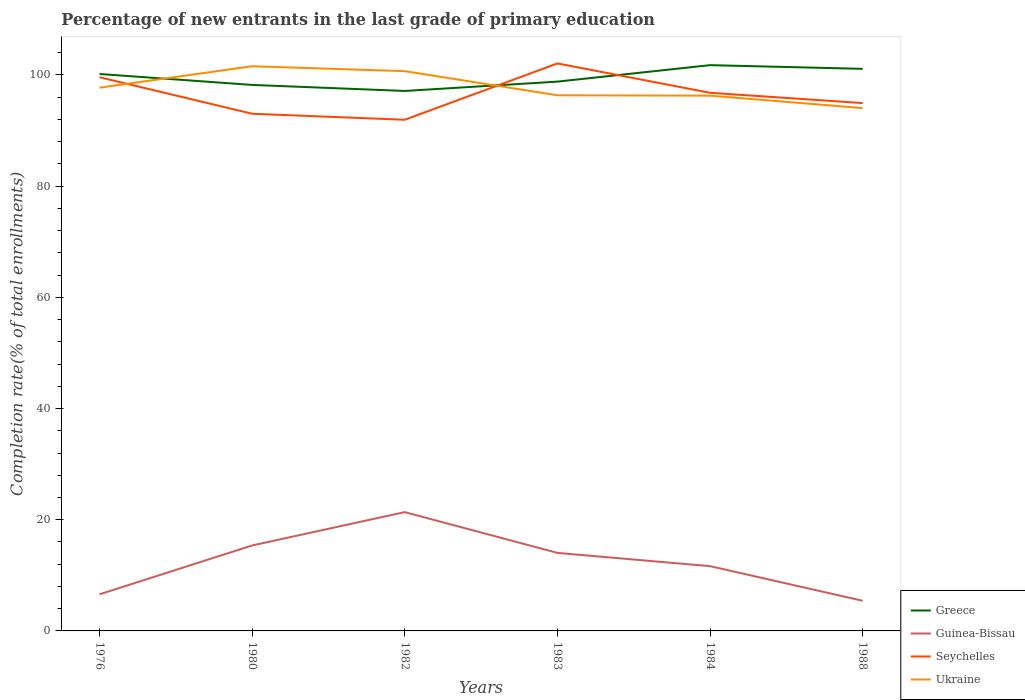How many different coloured lines are there?
Make the answer very short. 4. Does the line corresponding to Ukraine intersect with the line corresponding to Guinea-Bissau?
Your answer should be compact. No. Across all years, what is the maximum percentage of new entrants in Ukraine?
Offer a very short reply. 94.04. In which year was the percentage of new entrants in Ukraine maximum?
Your response must be concise. 1988. What is the total percentage of new entrants in Guinea-Bissau in the graph?
Give a very brief answer. -7.45. What is the difference between the highest and the second highest percentage of new entrants in Greece?
Your response must be concise. 4.64. What is the difference between the highest and the lowest percentage of new entrants in Ukraine?
Make the answer very short. 2. How many lines are there?
Keep it short and to the point. 4. How many years are there in the graph?
Your answer should be very brief. 6. Are the values on the major ticks of Y-axis written in scientific E-notation?
Provide a short and direct response. No. Does the graph contain grids?
Give a very brief answer. No. Where does the legend appear in the graph?
Give a very brief answer. Bottom right. How many legend labels are there?
Give a very brief answer. 4. How are the legend labels stacked?
Your answer should be compact. Vertical. What is the title of the graph?
Your answer should be compact. Percentage of new entrants in the last grade of primary education. Does "Middle East & North Africa (developing only)" appear as one of the legend labels in the graph?
Provide a succinct answer. No. What is the label or title of the Y-axis?
Offer a terse response. Completion rate(% of total enrollments). What is the Completion rate(% of total enrollments) in Greece in 1976?
Your answer should be very brief. 100.17. What is the Completion rate(% of total enrollments) of Guinea-Bissau in 1976?
Offer a very short reply. 6.58. What is the Completion rate(% of total enrollments) in Seychelles in 1976?
Your answer should be very brief. 99.58. What is the Completion rate(% of total enrollments) in Ukraine in 1976?
Offer a very short reply. 97.71. What is the Completion rate(% of total enrollments) in Greece in 1980?
Keep it short and to the point. 98.2. What is the Completion rate(% of total enrollments) in Guinea-Bissau in 1980?
Ensure brevity in your answer.  15.37. What is the Completion rate(% of total enrollments) of Seychelles in 1980?
Your answer should be very brief. 93.02. What is the Completion rate(% of total enrollments) of Ukraine in 1980?
Make the answer very short. 101.56. What is the Completion rate(% of total enrollments) in Greece in 1982?
Your response must be concise. 97.12. What is the Completion rate(% of total enrollments) of Guinea-Bissau in 1982?
Offer a terse response. 21.37. What is the Completion rate(% of total enrollments) in Seychelles in 1982?
Ensure brevity in your answer.  91.94. What is the Completion rate(% of total enrollments) of Ukraine in 1982?
Provide a short and direct response. 100.68. What is the Completion rate(% of total enrollments) of Greece in 1983?
Your answer should be compact. 98.8. What is the Completion rate(% of total enrollments) of Guinea-Bissau in 1983?
Your response must be concise. 14.03. What is the Completion rate(% of total enrollments) of Seychelles in 1983?
Offer a terse response. 102.07. What is the Completion rate(% of total enrollments) in Ukraine in 1983?
Ensure brevity in your answer.  96.34. What is the Completion rate(% of total enrollments) in Greece in 1984?
Your response must be concise. 101.76. What is the Completion rate(% of total enrollments) of Guinea-Bissau in 1984?
Your answer should be very brief. 11.65. What is the Completion rate(% of total enrollments) of Seychelles in 1984?
Your response must be concise. 96.79. What is the Completion rate(% of total enrollments) of Ukraine in 1984?
Provide a succinct answer. 96.27. What is the Completion rate(% of total enrollments) in Greece in 1988?
Offer a very short reply. 101.1. What is the Completion rate(% of total enrollments) of Guinea-Bissau in 1988?
Your answer should be compact. 5.42. What is the Completion rate(% of total enrollments) in Seychelles in 1988?
Make the answer very short. 94.94. What is the Completion rate(% of total enrollments) of Ukraine in 1988?
Provide a short and direct response. 94.04. Across all years, what is the maximum Completion rate(% of total enrollments) in Greece?
Make the answer very short. 101.76. Across all years, what is the maximum Completion rate(% of total enrollments) of Guinea-Bissau?
Your answer should be very brief. 21.37. Across all years, what is the maximum Completion rate(% of total enrollments) of Seychelles?
Provide a succinct answer. 102.07. Across all years, what is the maximum Completion rate(% of total enrollments) in Ukraine?
Provide a succinct answer. 101.56. Across all years, what is the minimum Completion rate(% of total enrollments) of Greece?
Your answer should be very brief. 97.12. Across all years, what is the minimum Completion rate(% of total enrollments) in Guinea-Bissau?
Give a very brief answer. 5.42. Across all years, what is the minimum Completion rate(% of total enrollments) of Seychelles?
Provide a succinct answer. 91.94. Across all years, what is the minimum Completion rate(% of total enrollments) of Ukraine?
Your answer should be very brief. 94.04. What is the total Completion rate(% of total enrollments) of Greece in the graph?
Give a very brief answer. 597.14. What is the total Completion rate(% of total enrollments) of Guinea-Bissau in the graph?
Provide a succinct answer. 74.43. What is the total Completion rate(% of total enrollments) in Seychelles in the graph?
Make the answer very short. 578.34. What is the total Completion rate(% of total enrollments) of Ukraine in the graph?
Your answer should be very brief. 586.6. What is the difference between the Completion rate(% of total enrollments) in Greece in 1976 and that in 1980?
Offer a terse response. 1.97. What is the difference between the Completion rate(% of total enrollments) of Guinea-Bissau in 1976 and that in 1980?
Ensure brevity in your answer.  -8.79. What is the difference between the Completion rate(% of total enrollments) of Seychelles in 1976 and that in 1980?
Your response must be concise. 6.56. What is the difference between the Completion rate(% of total enrollments) of Ukraine in 1976 and that in 1980?
Offer a very short reply. -3.86. What is the difference between the Completion rate(% of total enrollments) in Greece in 1976 and that in 1982?
Ensure brevity in your answer.  3.05. What is the difference between the Completion rate(% of total enrollments) in Guinea-Bissau in 1976 and that in 1982?
Make the answer very short. -14.78. What is the difference between the Completion rate(% of total enrollments) in Seychelles in 1976 and that in 1982?
Make the answer very short. 7.64. What is the difference between the Completion rate(% of total enrollments) of Ukraine in 1976 and that in 1982?
Provide a succinct answer. -2.97. What is the difference between the Completion rate(% of total enrollments) of Greece in 1976 and that in 1983?
Offer a very short reply. 1.37. What is the difference between the Completion rate(% of total enrollments) in Guinea-Bissau in 1976 and that in 1983?
Provide a short and direct response. -7.45. What is the difference between the Completion rate(% of total enrollments) in Seychelles in 1976 and that in 1983?
Provide a short and direct response. -2.48. What is the difference between the Completion rate(% of total enrollments) in Ukraine in 1976 and that in 1983?
Keep it short and to the point. 1.37. What is the difference between the Completion rate(% of total enrollments) in Greece in 1976 and that in 1984?
Your response must be concise. -1.59. What is the difference between the Completion rate(% of total enrollments) of Guinea-Bissau in 1976 and that in 1984?
Keep it short and to the point. -5.07. What is the difference between the Completion rate(% of total enrollments) in Seychelles in 1976 and that in 1984?
Offer a terse response. 2.79. What is the difference between the Completion rate(% of total enrollments) in Ukraine in 1976 and that in 1984?
Keep it short and to the point. 1.43. What is the difference between the Completion rate(% of total enrollments) of Greece in 1976 and that in 1988?
Offer a terse response. -0.93. What is the difference between the Completion rate(% of total enrollments) of Guinea-Bissau in 1976 and that in 1988?
Your answer should be compact. 1.16. What is the difference between the Completion rate(% of total enrollments) of Seychelles in 1976 and that in 1988?
Keep it short and to the point. 4.64. What is the difference between the Completion rate(% of total enrollments) in Ukraine in 1976 and that in 1988?
Your answer should be very brief. 3.67. What is the difference between the Completion rate(% of total enrollments) in Greece in 1980 and that in 1982?
Provide a succinct answer. 1.09. What is the difference between the Completion rate(% of total enrollments) in Guinea-Bissau in 1980 and that in 1982?
Provide a succinct answer. -5.99. What is the difference between the Completion rate(% of total enrollments) of Seychelles in 1980 and that in 1982?
Give a very brief answer. 1.08. What is the difference between the Completion rate(% of total enrollments) of Ukraine in 1980 and that in 1982?
Your answer should be very brief. 0.88. What is the difference between the Completion rate(% of total enrollments) of Greece in 1980 and that in 1983?
Your answer should be very brief. -0.59. What is the difference between the Completion rate(% of total enrollments) in Guinea-Bissau in 1980 and that in 1983?
Your answer should be very brief. 1.34. What is the difference between the Completion rate(% of total enrollments) in Seychelles in 1980 and that in 1983?
Ensure brevity in your answer.  -9.05. What is the difference between the Completion rate(% of total enrollments) of Ukraine in 1980 and that in 1983?
Ensure brevity in your answer.  5.22. What is the difference between the Completion rate(% of total enrollments) in Greece in 1980 and that in 1984?
Your response must be concise. -3.56. What is the difference between the Completion rate(% of total enrollments) of Guinea-Bissau in 1980 and that in 1984?
Your answer should be very brief. 3.72. What is the difference between the Completion rate(% of total enrollments) in Seychelles in 1980 and that in 1984?
Provide a short and direct response. -3.77. What is the difference between the Completion rate(% of total enrollments) of Ukraine in 1980 and that in 1984?
Make the answer very short. 5.29. What is the difference between the Completion rate(% of total enrollments) in Greece in 1980 and that in 1988?
Provide a succinct answer. -2.89. What is the difference between the Completion rate(% of total enrollments) of Guinea-Bissau in 1980 and that in 1988?
Offer a very short reply. 9.95. What is the difference between the Completion rate(% of total enrollments) in Seychelles in 1980 and that in 1988?
Provide a succinct answer. -1.92. What is the difference between the Completion rate(% of total enrollments) in Ukraine in 1980 and that in 1988?
Ensure brevity in your answer.  7.53. What is the difference between the Completion rate(% of total enrollments) of Greece in 1982 and that in 1983?
Provide a succinct answer. -1.68. What is the difference between the Completion rate(% of total enrollments) in Guinea-Bissau in 1982 and that in 1983?
Make the answer very short. 7.33. What is the difference between the Completion rate(% of total enrollments) in Seychelles in 1982 and that in 1983?
Your answer should be very brief. -10.13. What is the difference between the Completion rate(% of total enrollments) in Ukraine in 1982 and that in 1983?
Your response must be concise. 4.34. What is the difference between the Completion rate(% of total enrollments) in Greece in 1982 and that in 1984?
Give a very brief answer. -4.64. What is the difference between the Completion rate(% of total enrollments) of Guinea-Bissau in 1982 and that in 1984?
Make the answer very short. 9.72. What is the difference between the Completion rate(% of total enrollments) in Seychelles in 1982 and that in 1984?
Make the answer very short. -4.85. What is the difference between the Completion rate(% of total enrollments) of Ukraine in 1982 and that in 1984?
Keep it short and to the point. 4.41. What is the difference between the Completion rate(% of total enrollments) of Greece in 1982 and that in 1988?
Your answer should be very brief. -3.98. What is the difference between the Completion rate(% of total enrollments) in Guinea-Bissau in 1982 and that in 1988?
Your answer should be very brief. 15.94. What is the difference between the Completion rate(% of total enrollments) of Seychelles in 1982 and that in 1988?
Ensure brevity in your answer.  -3. What is the difference between the Completion rate(% of total enrollments) of Ukraine in 1982 and that in 1988?
Your answer should be compact. 6.64. What is the difference between the Completion rate(% of total enrollments) of Greece in 1983 and that in 1984?
Keep it short and to the point. -2.96. What is the difference between the Completion rate(% of total enrollments) of Guinea-Bissau in 1983 and that in 1984?
Offer a terse response. 2.39. What is the difference between the Completion rate(% of total enrollments) in Seychelles in 1983 and that in 1984?
Give a very brief answer. 5.28. What is the difference between the Completion rate(% of total enrollments) in Ukraine in 1983 and that in 1984?
Your answer should be very brief. 0.07. What is the difference between the Completion rate(% of total enrollments) in Greece in 1983 and that in 1988?
Offer a very short reply. -2.3. What is the difference between the Completion rate(% of total enrollments) in Guinea-Bissau in 1983 and that in 1988?
Offer a very short reply. 8.61. What is the difference between the Completion rate(% of total enrollments) of Seychelles in 1983 and that in 1988?
Provide a succinct answer. 7.13. What is the difference between the Completion rate(% of total enrollments) of Ukraine in 1983 and that in 1988?
Keep it short and to the point. 2.3. What is the difference between the Completion rate(% of total enrollments) in Greece in 1984 and that in 1988?
Keep it short and to the point. 0.66. What is the difference between the Completion rate(% of total enrollments) of Guinea-Bissau in 1984 and that in 1988?
Give a very brief answer. 6.22. What is the difference between the Completion rate(% of total enrollments) of Seychelles in 1984 and that in 1988?
Ensure brevity in your answer.  1.85. What is the difference between the Completion rate(% of total enrollments) in Ukraine in 1984 and that in 1988?
Your response must be concise. 2.24. What is the difference between the Completion rate(% of total enrollments) in Greece in 1976 and the Completion rate(% of total enrollments) in Guinea-Bissau in 1980?
Your answer should be very brief. 84.8. What is the difference between the Completion rate(% of total enrollments) of Greece in 1976 and the Completion rate(% of total enrollments) of Seychelles in 1980?
Give a very brief answer. 7.15. What is the difference between the Completion rate(% of total enrollments) in Greece in 1976 and the Completion rate(% of total enrollments) in Ukraine in 1980?
Offer a very short reply. -1.4. What is the difference between the Completion rate(% of total enrollments) of Guinea-Bissau in 1976 and the Completion rate(% of total enrollments) of Seychelles in 1980?
Offer a terse response. -86.44. What is the difference between the Completion rate(% of total enrollments) in Guinea-Bissau in 1976 and the Completion rate(% of total enrollments) in Ukraine in 1980?
Provide a short and direct response. -94.98. What is the difference between the Completion rate(% of total enrollments) in Seychelles in 1976 and the Completion rate(% of total enrollments) in Ukraine in 1980?
Your answer should be very brief. -1.98. What is the difference between the Completion rate(% of total enrollments) in Greece in 1976 and the Completion rate(% of total enrollments) in Guinea-Bissau in 1982?
Make the answer very short. 78.8. What is the difference between the Completion rate(% of total enrollments) of Greece in 1976 and the Completion rate(% of total enrollments) of Seychelles in 1982?
Ensure brevity in your answer.  8.23. What is the difference between the Completion rate(% of total enrollments) of Greece in 1976 and the Completion rate(% of total enrollments) of Ukraine in 1982?
Keep it short and to the point. -0.51. What is the difference between the Completion rate(% of total enrollments) in Guinea-Bissau in 1976 and the Completion rate(% of total enrollments) in Seychelles in 1982?
Your answer should be very brief. -85.36. What is the difference between the Completion rate(% of total enrollments) in Guinea-Bissau in 1976 and the Completion rate(% of total enrollments) in Ukraine in 1982?
Your response must be concise. -94.1. What is the difference between the Completion rate(% of total enrollments) in Seychelles in 1976 and the Completion rate(% of total enrollments) in Ukraine in 1982?
Provide a succinct answer. -1.1. What is the difference between the Completion rate(% of total enrollments) of Greece in 1976 and the Completion rate(% of total enrollments) of Guinea-Bissau in 1983?
Make the answer very short. 86.13. What is the difference between the Completion rate(% of total enrollments) of Greece in 1976 and the Completion rate(% of total enrollments) of Seychelles in 1983?
Offer a terse response. -1.9. What is the difference between the Completion rate(% of total enrollments) in Greece in 1976 and the Completion rate(% of total enrollments) in Ukraine in 1983?
Give a very brief answer. 3.83. What is the difference between the Completion rate(% of total enrollments) in Guinea-Bissau in 1976 and the Completion rate(% of total enrollments) in Seychelles in 1983?
Your response must be concise. -95.48. What is the difference between the Completion rate(% of total enrollments) of Guinea-Bissau in 1976 and the Completion rate(% of total enrollments) of Ukraine in 1983?
Give a very brief answer. -89.76. What is the difference between the Completion rate(% of total enrollments) of Seychelles in 1976 and the Completion rate(% of total enrollments) of Ukraine in 1983?
Your answer should be compact. 3.24. What is the difference between the Completion rate(% of total enrollments) in Greece in 1976 and the Completion rate(% of total enrollments) in Guinea-Bissau in 1984?
Ensure brevity in your answer.  88.52. What is the difference between the Completion rate(% of total enrollments) of Greece in 1976 and the Completion rate(% of total enrollments) of Seychelles in 1984?
Your answer should be very brief. 3.38. What is the difference between the Completion rate(% of total enrollments) of Greece in 1976 and the Completion rate(% of total enrollments) of Ukraine in 1984?
Your answer should be compact. 3.89. What is the difference between the Completion rate(% of total enrollments) in Guinea-Bissau in 1976 and the Completion rate(% of total enrollments) in Seychelles in 1984?
Your answer should be compact. -90.21. What is the difference between the Completion rate(% of total enrollments) in Guinea-Bissau in 1976 and the Completion rate(% of total enrollments) in Ukraine in 1984?
Provide a short and direct response. -89.69. What is the difference between the Completion rate(% of total enrollments) in Seychelles in 1976 and the Completion rate(% of total enrollments) in Ukraine in 1984?
Your answer should be very brief. 3.31. What is the difference between the Completion rate(% of total enrollments) in Greece in 1976 and the Completion rate(% of total enrollments) in Guinea-Bissau in 1988?
Your answer should be compact. 94.74. What is the difference between the Completion rate(% of total enrollments) in Greece in 1976 and the Completion rate(% of total enrollments) in Seychelles in 1988?
Offer a terse response. 5.23. What is the difference between the Completion rate(% of total enrollments) in Greece in 1976 and the Completion rate(% of total enrollments) in Ukraine in 1988?
Ensure brevity in your answer.  6.13. What is the difference between the Completion rate(% of total enrollments) of Guinea-Bissau in 1976 and the Completion rate(% of total enrollments) of Seychelles in 1988?
Provide a succinct answer. -88.35. What is the difference between the Completion rate(% of total enrollments) in Guinea-Bissau in 1976 and the Completion rate(% of total enrollments) in Ukraine in 1988?
Ensure brevity in your answer.  -87.45. What is the difference between the Completion rate(% of total enrollments) of Seychelles in 1976 and the Completion rate(% of total enrollments) of Ukraine in 1988?
Provide a succinct answer. 5.55. What is the difference between the Completion rate(% of total enrollments) in Greece in 1980 and the Completion rate(% of total enrollments) in Guinea-Bissau in 1982?
Provide a succinct answer. 76.84. What is the difference between the Completion rate(% of total enrollments) of Greece in 1980 and the Completion rate(% of total enrollments) of Seychelles in 1982?
Ensure brevity in your answer.  6.26. What is the difference between the Completion rate(% of total enrollments) in Greece in 1980 and the Completion rate(% of total enrollments) in Ukraine in 1982?
Make the answer very short. -2.48. What is the difference between the Completion rate(% of total enrollments) in Guinea-Bissau in 1980 and the Completion rate(% of total enrollments) in Seychelles in 1982?
Ensure brevity in your answer.  -76.57. What is the difference between the Completion rate(% of total enrollments) in Guinea-Bissau in 1980 and the Completion rate(% of total enrollments) in Ukraine in 1982?
Provide a succinct answer. -85.31. What is the difference between the Completion rate(% of total enrollments) in Seychelles in 1980 and the Completion rate(% of total enrollments) in Ukraine in 1982?
Make the answer very short. -7.66. What is the difference between the Completion rate(% of total enrollments) in Greece in 1980 and the Completion rate(% of total enrollments) in Guinea-Bissau in 1983?
Offer a very short reply. 84.17. What is the difference between the Completion rate(% of total enrollments) in Greece in 1980 and the Completion rate(% of total enrollments) in Seychelles in 1983?
Your answer should be compact. -3.86. What is the difference between the Completion rate(% of total enrollments) of Greece in 1980 and the Completion rate(% of total enrollments) of Ukraine in 1983?
Your answer should be compact. 1.86. What is the difference between the Completion rate(% of total enrollments) in Guinea-Bissau in 1980 and the Completion rate(% of total enrollments) in Seychelles in 1983?
Keep it short and to the point. -86.69. What is the difference between the Completion rate(% of total enrollments) of Guinea-Bissau in 1980 and the Completion rate(% of total enrollments) of Ukraine in 1983?
Offer a very short reply. -80.97. What is the difference between the Completion rate(% of total enrollments) of Seychelles in 1980 and the Completion rate(% of total enrollments) of Ukraine in 1983?
Your answer should be very brief. -3.32. What is the difference between the Completion rate(% of total enrollments) of Greece in 1980 and the Completion rate(% of total enrollments) of Guinea-Bissau in 1984?
Provide a succinct answer. 86.55. What is the difference between the Completion rate(% of total enrollments) in Greece in 1980 and the Completion rate(% of total enrollments) in Seychelles in 1984?
Provide a succinct answer. 1.41. What is the difference between the Completion rate(% of total enrollments) of Greece in 1980 and the Completion rate(% of total enrollments) of Ukraine in 1984?
Offer a terse response. 1.93. What is the difference between the Completion rate(% of total enrollments) of Guinea-Bissau in 1980 and the Completion rate(% of total enrollments) of Seychelles in 1984?
Your answer should be very brief. -81.42. What is the difference between the Completion rate(% of total enrollments) of Guinea-Bissau in 1980 and the Completion rate(% of total enrollments) of Ukraine in 1984?
Make the answer very short. -80.9. What is the difference between the Completion rate(% of total enrollments) in Seychelles in 1980 and the Completion rate(% of total enrollments) in Ukraine in 1984?
Keep it short and to the point. -3.25. What is the difference between the Completion rate(% of total enrollments) in Greece in 1980 and the Completion rate(% of total enrollments) in Guinea-Bissau in 1988?
Your response must be concise. 92.78. What is the difference between the Completion rate(% of total enrollments) of Greece in 1980 and the Completion rate(% of total enrollments) of Seychelles in 1988?
Provide a short and direct response. 3.27. What is the difference between the Completion rate(% of total enrollments) in Greece in 1980 and the Completion rate(% of total enrollments) in Ukraine in 1988?
Make the answer very short. 4.17. What is the difference between the Completion rate(% of total enrollments) of Guinea-Bissau in 1980 and the Completion rate(% of total enrollments) of Seychelles in 1988?
Ensure brevity in your answer.  -79.56. What is the difference between the Completion rate(% of total enrollments) in Guinea-Bissau in 1980 and the Completion rate(% of total enrollments) in Ukraine in 1988?
Make the answer very short. -78.66. What is the difference between the Completion rate(% of total enrollments) of Seychelles in 1980 and the Completion rate(% of total enrollments) of Ukraine in 1988?
Offer a terse response. -1.02. What is the difference between the Completion rate(% of total enrollments) in Greece in 1982 and the Completion rate(% of total enrollments) in Guinea-Bissau in 1983?
Your answer should be very brief. 83.08. What is the difference between the Completion rate(% of total enrollments) of Greece in 1982 and the Completion rate(% of total enrollments) of Seychelles in 1983?
Make the answer very short. -4.95. What is the difference between the Completion rate(% of total enrollments) in Greece in 1982 and the Completion rate(% of total enrollments) in Ukraine in 1983?
Provide a succinct answer. 0.78. What is the difference between the Completion rate(% of total enrollments) of Guinea-Bissau in 1982 and the Completion rate(% of total enrollments) of Seychelles in 1983?
Offer a very short reply. -80.7. What is the difference between the Completion rate(% of total enrollments) of Guinea-Bissau in 1982 and the Completion rate(% of total enrollments) of Ukraine in 1983?
Keep it short and to the point. -74.97. What is the difference between the Completion rate(% of total enrollments) in Seychelles in 1982 and the Completion rate(% of total enrollments) in Ukraine in 1983?
Make the answer very short. -4.4. What is the difference between the Completion rate(% of total enrollments) in Greece in 1982 and the Completion rate(% of total enrollments) in Guinea-Bissau in 1984?
Your response must be concise. 85.47. What is the difference between the Completion rate(% of total enrollments) of Greece in 1982 and the Completion rate(% of total enrollments) of Seychelles in 1984?
Keep it short and to the point. 0.33. What is the difference between the Completion rate(% of total enrollments) of Greece in 1982 and the Completion rate(% of total enrollments) of Ukraine in 1984?
Keep it short and to the point. 0.84. What is the difference between the Completion rate(% of total enrollments) of Guinea-Bissau in 1982 and the Completion rate(% of total enrollments) of Seychelles in 1984?
Give a very brief answer. -75.42. What is the difference between the Completion rate(% of total enrollments) in Guinea-Bissau in 1982 and the Completion rate(% of total enrollments) in Ukraine in 1984?
Provide a succinct answer. -74.91. What is the difference between the Completion rate(% of total enrollments) of Seychelles in 1982 and the Completion rate(% of total enrollments) of Ukraine in 1984?
Offer a very short reply. -4.33. What is the difference between the Completion rate(% of total enrollments) of Greece in 1982 and the Completion rate(% of total enrollments) of Guinea-Bissau in 1988?
Offer a very short reply. 91.69. What is the difference between the Completion rate(% of total enrollments) in Greece in 1982 and the Completion rate(% of total enrollments) in Seychelles in 1988?
Your answer should be very brief. 2.18. What is the difference between the Completion rate(% of total enrollments) in Greece in 1982 and the Completion rate(% of total enrollments) in Ukraine in 1988?
Give a very brief answer. 3.08. What is the difference between the Completion rate(% of total enrollments) in Guinea-Bissau in 1982 and the Completion rate(% of total enrollments) in Seychelles in 1988?
Keep it short and to the point. -73.57. What is the difference between the Completion rate(% of total enrollments) of Guinea-Bissau in 1982 and the Completion rate(% of total enrollments) of Ukraine in 1988?
Offer a very short reply. -72.67. What is the difference between the Completion rate(% of total enrollments) in Seychelles in 1982 and the Completion rate(% of total enrollments) in Ukraine in 1988?
Provide a short and direct response. -2.1. What is the difference between the Completion rate(% of total enrollments) of Greece in 1983 and the Completion rate(% of total enrollments) of Guinea-Bissau in 1984?
Ensure brevity in your answer.  87.15. What is the difference between the Completion rate(% of total enrollments) of Greece in 1983 and the Completion rate(% of total enrollments) of Seychelles in 1984?
Offer a terse response. 2.01. What is the difference between the Completion rate(% of total enrollments) of Greece in 1983 and the Completion rate(% of total enrollments) of Ukraine in 1984?
Your response must be concise. 2.52. What is the difference between the Completion rate(% of total enrollments) in Guinea-Bissau in 1983 and the Completion rate(% of total enrollments) in Seychelles in 1984?
Make the answer very short. -82.76. What is the difference between the Completion rate(% of total enrollments) in Guinea-Bissau in 1983 and the Completion rate(% of total enrollments) in Ukraine in 1984?
Offer a very short reply. -82.24. What is the difference between the Completion rate(% of total enrollments) of Seychelles in 1983 and the Completion rate(% of total enrollments) of Ukraine in 1984?
Your response must be concise. 5.79. What is the difference between the Completion rate(% of total enrollments) in Greece in 1983 and the Completion rate(% of total enrollments) in Guinea-Bissau in 1988?
Offer a very short reply. 93.37. What is the difference between the Completion rate(% of total enrollments) in Greece in 1983 and the Completion rate(% of total enrollments) in Seychelles in 1988?
Give a very brief answer. 3.86. What is the difference between the Completion rate(% of total enrollments) in Greece in 1983 and the Completion rate(% of total enrollments) in Ukraine in 1988?
Give a very brief answer. 4.76. What is the difference between the Completion rate(% of total enrollments) in Guinea-Bissau in 1983 and the Completion rate(% of total enrollments) in Seychelles in 1988?
Give a very brief answer. -80.9. What is the difference between the Completion rate(% of total enrollments) in Guinea-Bissau in 1983 and the Completion rate(% of total enrollments) in Ukraine in 1988?
Give a very brief answer. -80. What is the difference between the Completion rate(% of total enrollments) in Seychelles in 1983 and the Completion rate(% of total enrollments) in Ukraine in 1988?
Ensure brevity in your answer.  8.03. What is the difference between the Completion rate(% of total enrollments) in Greece in 1984 and the Completion rate(% of total enrollments) in Guinea-Bissau in 1988?
Your response must be concise. 96.33. What is the difference between the Completion rate(% of total enrollments) in Greece in 1984 and the Completion rate(% of total enrollments) in Seychelles in 1988?
Offer a very short reply. 6.82. What is the difference between the Completion rate(% of total enrollments) in Greece in 1984 and the Completion rate(% of total enrollments) in Ukraine in 1988?
Make the answer very short. 7.72. What is the difference between the Completion rate(% of total enrollments) in Guinea-Bissau in 1984 and the Completion rate(% of total enrollments) in Seychelles in 1988?
Your answer should be compact. -83.29. What is the difference between the Completion rate(% of total enrollments) in Guinea-Bissau in 1984 and the Completion rate(% of total enrollments) in Ukraine in 1988?
Your response must be concise. -82.39. What is the difference between the Completion rate(% of total enrollments) in Seychelles in 1984 and the Completion rate(% of total enrollments) in Ukraine in 1988?
Give a very brief answer. 2.75. What is the average Completion rate(% of total enrollments) in Greece per year?
Provide a short and direct response. 99.52. What is the average Completion rate(% of total enrollments) of Guinea-Bissau per year?
Your answer should be very brief. 12.41. What is the average Completion rate(% of total enrollments) in Seychelles per year?
Ensure brevity in your answer.  96.39. What is the average Completion rate(% of total enrollments) of Ukraine per year?
Make the answer very short. 97.77. In the year 1976, what is the difference between the Completion rate(% of total enrollments) of Greece and Completion rate(% of total enrollments) of Guinea-Bissau?
Keep it short and to the point. 93.59. In the year 1976, what is the difference between the Completion rate(% of total enrollments) in Greece and Completion rate(% of total enrollments) in Seychelles?
Your response must be concise. 0.59. In the year 1976, what is the difference between the Completion rate(% of total enrollments) of Greece and Completion rate(% of total enrollments) of Ukraine?
Give a very brief answer. 2.46. In the year 1976, what is the difference between the Completion rate(% of total enrollments) in Guinea-Bissau and Completion rate(% of total enrollments) in Seychelles?
Your answer should be very brief. -93. In the year 1976, what is the difference between the Completion rate(% of total enrollments) in Guinea-Bissau and Completion rate(% of total enrollments) in Ukraine?
Provide a succinct answer. -91.12. In the year 1976, what is the difference between the Completion rate(% of total enrollments) in Seychelles and Completion rate(% of total enrollments) in Ukraine?
Offer a terse response. 1.88. In the year 1980, what is the difference between the Completion rate(% of total enrollments) of Greece and Completion rate(% of total enrollments) of Guinea-Bissau?
Provide a short and direct response. 82.83. In the year 1980, what is the difference between the Completion rate(% of total enrollments) of Greece and Completion rate(% of total enrollments) of Seychelles?
Your answer should be very brief. 5.18. In the year 1980, what is the difference between the Completion rate(% of total enrollments) in Greece and Completion rate(% of total enrollments) in Ukraine?
Make the answer very short. -3.36. In the year 1980, what is the difference between the Completion rate(% of total enrollments) in Guinea-Bissau and Completion rate(% of total enrollments) in Seychelles?
Your response must be concise. -77.65. In the year 1980, what is the difference between the Completion rate(% of total enrollments) in Guinea-Bissau and Completion rate(% of total enrollments) in Ukraine?
Provide a short and direct response. -86.19. In the year 1980, what is the difference between the Completion rate(% of total enrollments) in Seychelles and Completion rate(% of total enrollments) in Ukraine?
Your answer should be compact. -8.55. In the year 1982, what is the difference between the Completion rate(% of total enrollments) of Greece and Completion rate(% of total enrollments) of Guinea-Bissau?
Provide a succinct answer. 75.75. In the year 1982, what is the difference between the Completion rate(% of total enrollments) of Greece and Completion rate(% of total enrollments) of Seychelles?
Offer a very short reply. 5.18. In the year 1982, what is the difference between the Completion rate(% of total enrollments) in Greece and Completion rate(% of total enrollments) in Ukraine?
Make the answer very short. -3.56. In the year 1982, what is the difference between the Completion rate(% of total enrollments) of Guinea-Bissau and Completion rate(% of total enrollments) of Seychelles?
Ensure brevity in your answer.  -70.57. In the year 1982, what is the difference between the Completion rate(% of total enrollments) of Guinea-Bissau and Completion rate(% of total enrollments) of Ukraine?
Provide a succinct answer. -79.31. In the year 1982, what is the difference between the Completion rate(% of total enrollments) of Seychelles and Completion rate(% of total enrollments) of Ukraine?
Offer a terse response. -8.74. In the year 1983, what is the difference between the Completion rate(% of total enrollments) in Greece and Completion rate(% of total enrollments) in Guinea-Bissau?
Your response must be concise. 84.76. In the year 1983, what is the difference between the Completion rate(% of total enrollments) in Greece and Completion rate(% of total enrollments) in Seychelles?
Offer a terse response. -3.27. In the year 1983, what is the difference between the Completion rate(% of total enrollments) of Greece and Completion rate(% of total enrollments) of Ukraine?
Provide a succinct answer. 2.46. In the year 1983, what is the difference between the Completion rate(% of total enrollments) in Guinea-Bissau and Completion rate(% of total enrollments) in Seychelles?
Offer a terse response. -88.03. In the year 1983, what is the difference between the Completion rate(% of total enrollments) in Guinea-Bissau and Completion rate(% of total enrollments) in Ukraine?
Your answer should be very brief. -82.31. In the year 1983, what is the difference between the Completion rate(% of total enrollments) in Seychelles and Completion rate(% of total enrollments) in Ukraine?
Offer a very short reply. 5.73. In the year 1984, what is the difference between the Completion rate(% of total enrollments) in Greece and Completion rate(% of total enrollments) in Guinea-Bissau?
Make the answer very short. 90.11. In the year 1984, what is the difference between the Completion rate(% of total enrollments) of Greece and Completion rate(% of total enrollments) of Seychelles?
Make the answer very short. 4.97. In the year 1984, what is the difference between the Completion rate(% of total enrollments) in Greece and Completion rate(% of total enrollments) in Ukraine?
Your response must be concise. 5.48. In the year 1984, what is the difference between the Completion rate(% of total enrollments) of Guinea-Bissau and Completion rate(% of total enrollments) of Seychelles?
Your answer should be very brief. -85.14. In the year 1984, what is the difference between the Completion rate(% of total enrollments) of Guinea-Bissau and Completion rate(% of total enrollments) of Ukraine?
Offer a very short reply. -84.62. In the year 1984, what is the difference between the Completion rate(% of total enrollments) of Seychelles and Completion rate(% of total enrollments) of Ukraine?
Your response must be concise. 0.52. In the year 1988, what is the difference between the Completion rate(% of total enrollments) of Greece and Completion rate(% of total enrollments) of Guinea-Bissau?
Your response must be concise. 95.67. In the year 1988, what is the difference between the Completion rate(% of total enrollments) of Greece and Completion rate(% of total enrollments) of Seychelles?
Provide a short and direct response. 6.16. In the year 1988, what is the difference between the Completion rate(% of total enrollments) in Greece and Completion rate(% of total enrollments) in Ukraine?
Provide a succinct answer. 7.06. In the year 1988, what is the difference between the Completion rate(% of total enrollments) in Guinea-Bissau and Completion rate(% of total enrollments) in Seychelles?
Ensure brevity in your answer.  -89.51. In the year 1988, what is the difference between the Completion rate(% of total enrollments) in Guinea-Bissau and Completion rate(% of total enrollments) in Ukraine?
Give a very brief answer. -88.61. In the year 1988, what is the difference between the Completion rate(% of total enrollments) of Seychelles and Completion rate(% of total enrollments) of Ukraine?
Ensure brevity in your answer.  0.9. What is the ratio of the Completion rate(% of total enrollments) of Greece in 1976 to that in 1980?
Make the answer very short. 1.02. What is the ratio of the Completion rate(% of total enrollments) in Guinea-Bissau in 1976 to that in 1980?
Give a very brief answer. 0.43. What is the ratio of the Completion rate(% of total enrollments) of Seychelles in 1976 to that in 1980?
Keep it short and to the point. 1.07. What is the ratio of the Completion rate(% of total enrollments) of Greece in 1976 to that in 1982?
Offer a very short reply. 1.03. What is the ratio of the Completion rate(% of total enrollments) of Guinea-Bissau in 1976 to that in 1982?
Keep it short and to the point. 0.31. What is the ratio of the Completion rate(% of total enrollments) in Seychelles in 1976 to that in 1982?
Your answer should be compact. 1.08. What is the ratio of the Completion rate(% of total enrollments) of Ukraine in 1976 to that in 1982?
Offer a terse response. 0.97. What is the ratio of the Completion rate(% of total enrollments) of Greece in 1976 to that in 1983?
Offer a very short reply. 1.01. What is the ratio of the Completion rate(% of total enrollments) of Guinea-Bissau in 1976 to that in 1983?
Your answer should be compact. 0.47. What is the ratio of the Completion rate(% of total enrollments) of Seychelles in 1976 to that in 1983?
Offer a very short reply. 0.98. What is the ratio of the Completion rate(% of total enrollments) in Ukraine in 1976 to that in 1983?
Give a very brief answer. 1.01. What is the ratio of the Completion rate(% of total enrollments) of Greece in 1976 to that in 1984?
Offer a very short reply. 0.98. What is the ratio of the Completion rate(% of total enrollments) of Guinea-Bissau in 1976 to that in 1984?
Offer a terse response. 0.57. What is the ratio of the Completion rate(% of total enrollments) in Seychelles in 1976 to that in 1984?
Your answer should be very brief. 1.03. What is the ratio of the Completion rate(% of total enrollments) in Ukraine in 1976 to that in 1984?
Your answer should be compact. 1.01. What is the ratio of the Completion rate(% of total enrollments) of Guinea-Bissau in 1976 to that in 1988?
Offer a very short reply. 1.21. What is the ratio of the Completion rate(% of total enrollments) of Seychelles in 1976 to that in 1988?
Your answer should be very brief. 1.05. What is the ratio of the Completion rate(% of total enrollments) in Ukraine in 1976 to that in 1988?
Your response must be concise. 1.04. What is the ratio of the Completion rate(% of total enrollments) of Greece in 1980 to that in 1982?
Provide a succinct answer. 1.01. What is the ratio of the Completion rate(% of total enrollments) of Guinea-Bissau in 1980 to that in 1982?
Give a very brief answer. 0.72. What is the ratio of the Completion rate(% of total enrollments) of Seychelles in 1980 to that in 1982?
Provide a short and direct response. 1.01. What is the ratio of the Completion rate(% of total enrollments) of Ukraine in 1980 to that in 1982?
Keep it short and to the point. 1.01. What is the ratio of the Completion rate(% of total enrollments) in Greece in 1980 to that in 1983?
Your answer should be compact. 0.99. What is the ratio of the Completion rate(% of total enrollments) in Guinea-Bissau in 1980 to that in 1983?
Ensure brevity in your answer.  1.1. What is the ratio of the Completion rate(% of total enrollments) in Seychelles in 1980 to that in 1983?
Provide a succinct answer. 0.91. What is the ratio of the Completion rate(% of total enrollments) in Ukraine in 1980 to that in 1983?
Ensure brevity in your answer.  1.05. What is the ratio of the Completion rate(% of total enrollments) in Greece in 1980 to that in 1984?
Your answer should be compact. 0.97. What is the ratio of the Completion rate(% of total enrollments) of Guinea-Bissau in 1980 to that in 1984?
Offer a very short reply. 1.32. What is the ratio of the Completion rate(% of total enrollments) in Ukraine in 1980 to that in 1984?
Your answer should be compact. 1.05. What is the ratio of the Completion rate(% of total enrollments) in Greece in 1980 to that in 1988?
Give a very brief answer. 0.97. What is the ratio of the Completion rate(% of total enrollments) in Guinea-Bissau in 1980 to that in 1988?
Your answer should be compact. 2.83. What is the ratio of the Completion rate(% of total enrollments) in Seychelles in 1980 to that in 1988?
Provide a short and direct response. 0.98. What is the ratio of the Completion rate(% of total enrollments) in Ukraine in 1980 to that in 1988?
Give a very brief answer. 1.08. What is the ratio of the Completion rate(% of total enrollments) in Guinea-Bissau in 1982 to that in 1983?
Offer a very short reply. 1.52. What is the ratio of the Completion rate(% of total enrollments) of Seychelles in 1982 to that in 1983?
Keep it short and to the point. 0.9. What is the ratio of the Completion rate(% of total enrollments) in Ukraine in 1982 to that in 1983?
Offer a very short reply. 1.04. What is the ratio of the Completion rate(% of total enrollments) in Greece in 1982 to that in 1984?
Your response must be concise. 0.95. What is the ratio of the Completion rate(% of total enrollments) in Guinea-Bissau in 1982 to that in 1984?
Provide a short and direct response. 1.83. What is the ratio of the Completion rate(% of total enrollments) in Seychelles in 1982 to that in 1984?
Your answer should be compact. 0.95. What is the ratio of the Completion rate(% of total enrollments) of Ukraine in 1982 to that in 1984?
Offer a very short reply. 1.05. What is the ratio of the Completion rate(% of total enrollments) of Greece in 1982 to that in 1988?
Provide a succinct answer. 0.96. What is the ratio of the Completion rate(% of total enrollments) of Guinea-Bissau in 1982 to that in 1988?
Give a very brief answer. 3.94. What is the ratio of the Completion rate(% of total enrollments) of Seychelles in 1982 to that in 1988?
Provide a succinct answer. 0.97. What is the ratio of the Completion rate(% of total enrollments) in Ukraine in 1982 to that in 1988?
Give a very brief answer. 1.07. What is the ratio of the Completion rate(% of total enrollments) in Greece in 1983 to that in 1984?
Your response must be concise. 0.97. What is the ratio of the Completion rate(% of total enrollments) of Guinea-Bissau in 1983 to that in 1984?
Give a very brief answer. 1.2. What is the ratio of the Completion rate(% of total enrollments) of Seychelles in 1983 to that in 1984?
Give a very brief answer. 1.05. What is the ratio of the Completion rate(% of total enrollments) in Ukraine in 1983 to that in 1984?
Give a very brief answer. 1. What is the ratio of the Completion rate(% of total enrollments) of Greece in 1983 to that in 1988?
Your response must be concise. 0.98. What is the ratio of the Completion rate(% of total enrollments) in Guinea-Bissau in 1983 to that in 1988?
Provide a succinct answer. 2.59. What is the ratio of the Completion rate(% of total enrollments) in Seychelles in 1983 to that in 1988?
Offer a terse response. 1.08. What is the ratio of the Completion rate(% of total enrollments) in Ukraine in 1983 to that in 1988?
Your answer should be very brief. 1.02. What is the ratio of the Completion rate(% of total enrollments) of Greece in 1984 to that in 1988?
Keep it short and to the point. 1.01. What is the ratio of the Completion rate(% of total enrollments) of Guinea-Bissau in 1984 to that in 1988?
Offer a terse response. 2.15. What is the ratio of the Completion rate(% of total enrollments) of Seychelles in 1984 to that in 1988?
Offer a very short reply. 1.02. What is the ratio of the Completion rate(% of total enrollments) in Ukraine in 1984 to that in 1988?
Your answer should be compact. 1.02. What is the difference between the highest and the second highest Completion rate(% of total enrollments) in Greece?
Provide a short and direct response. 0.66. What is the difference between the highest and the second highest Completion rate(% of total enrollments) of Guinea-Bissau?
Provide a short and direct response. 5.99. What is the difference between the highest and the second highest Completion rate(% of total enrollments) in Seychelles?
Ensure brevity in your answer.  2.48. What is the difference between the highest and the second highest Completion rate(% of total enrollments) of Ukraine?
Ensure brevity in your answer.  0.88. What is the difference between the highest and the lowest Completion rate(% of total enrollments) in Greece?
Provide a succinct answer. 4.64. What is the difference between the highest and the lowest Completion rate(% of total enrollments) in Guinea-Bissau?
Your answer should be very brief. 15.94. What is the difference between the highest and the lowest Completion rate(% of total enrollments) of Seychelles?
Your response must be concise. 10.13. What is the difference between the highest and the lowest Completion rate(% of total enrollments) in Ukraine?
Your answer should be very brief. 7.53. 